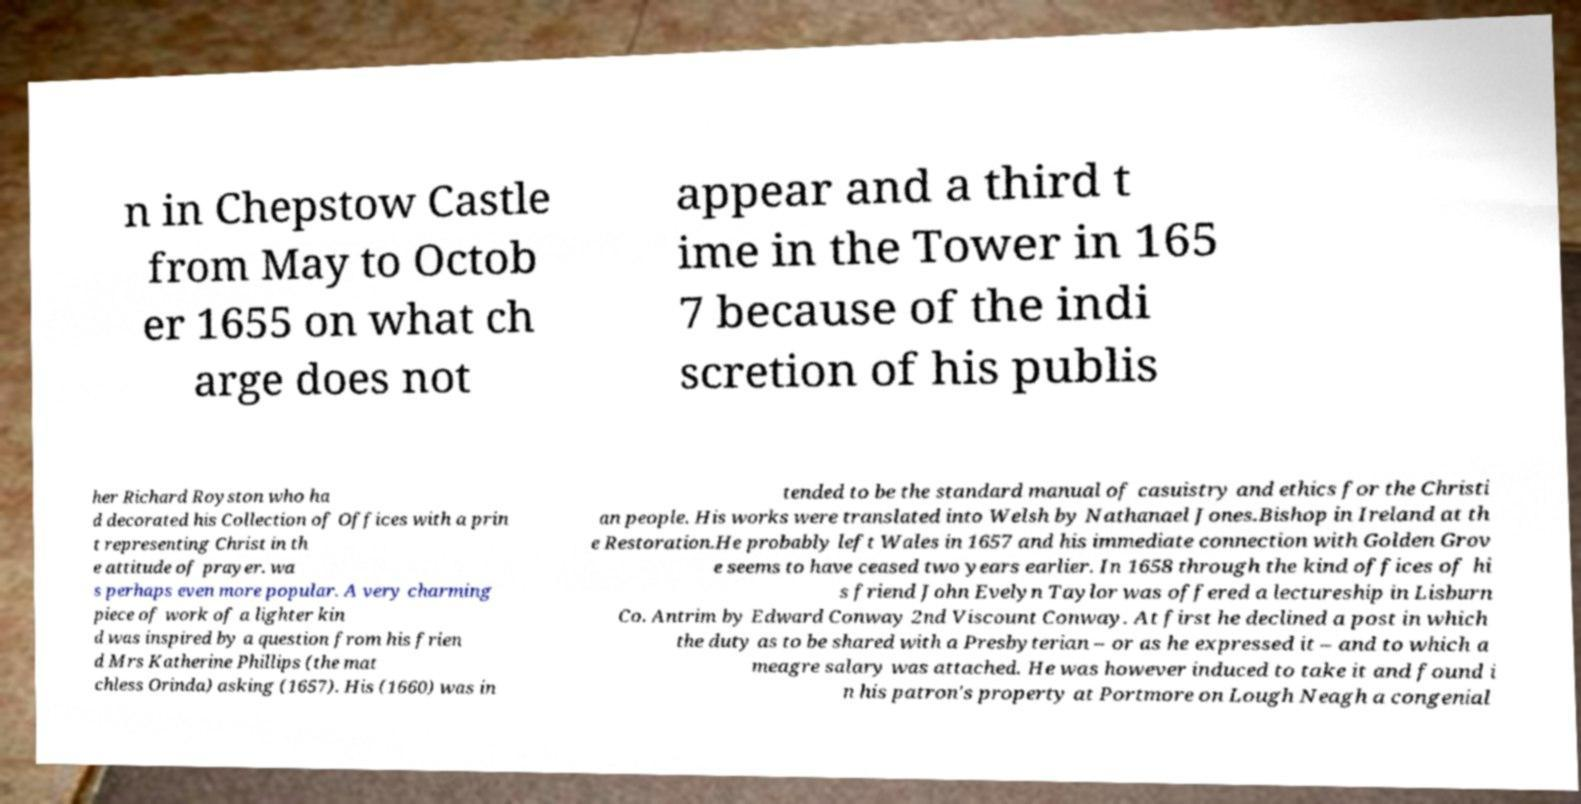Please read and relay the text visible in this image. What does it say? n in Chepstow Castle from May to Octob er 1655 on what ch arge does not appear and a third t ime in the Tower in 165 7 because of the indi scretion of his publis her Richard Royston who ha d decorated his Collection of Offices with a prin t representing Christ in th e attitude of prayer. wa s perhaps even more popular. A very charming piece of work of a lighter kin d was inspired by a question from his frien d Mrs Katherine Phillips (the mat chless Orinda) asking (1657). His (1660) was in tended to be the standard manual of casuistry and ethics for the Christi an people. His works were translated into Welsh by Nathanael Jones.Bishop in Ireland at th e Restoration.He probably left Wales in 1657 and his immediate connection with Golden Grov e seems to have ceased two years earlier. In 1658 through the kind offices of hi s friend John Evelyn Taylor was offered a lectureship in Lisburn Co. Antrim by Edward Conway 2nd Viscount Conway. At first he declined a post in which the duty as to be shared with a Presbyterian – or as he expressed it – and to which a meagre salary was attached. He was however induced to take it and found i n his patron's property at Portmore on Lough Neagh a congenial 